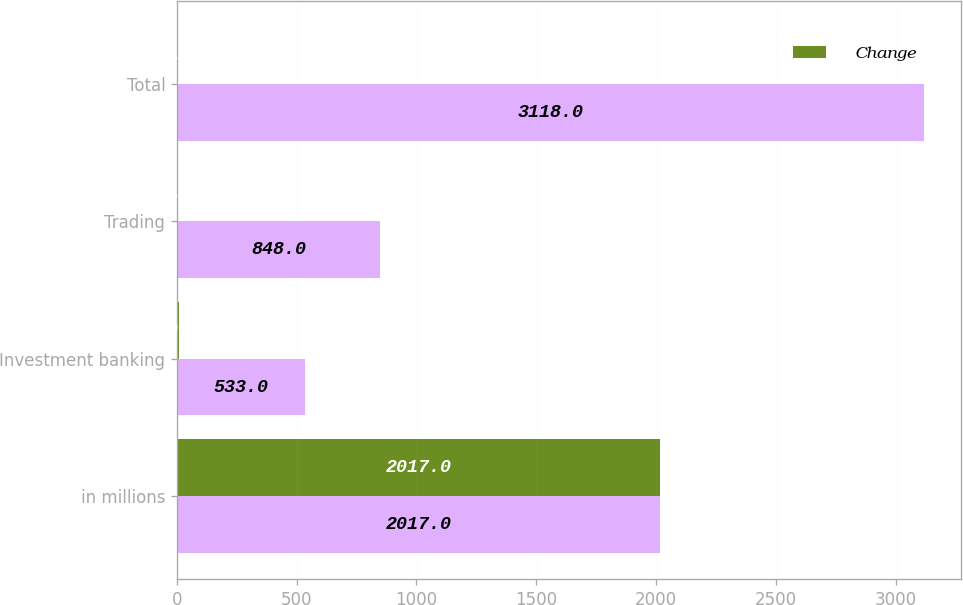Convert chart. <chart><loc_0><loc_0><loc_500><loc_500><stacked_bar_chart><ecel><fcel>in millions<fcel>Investment banking<fcel>Trading<fcel>Total<nl><fcel>nan<fcel>2017<fcel>533<fcel>848<fcel>3118<nl><fcel>Change<fcel>2017<fcel>10<fcel>2<fcel>1<nl></chart> 